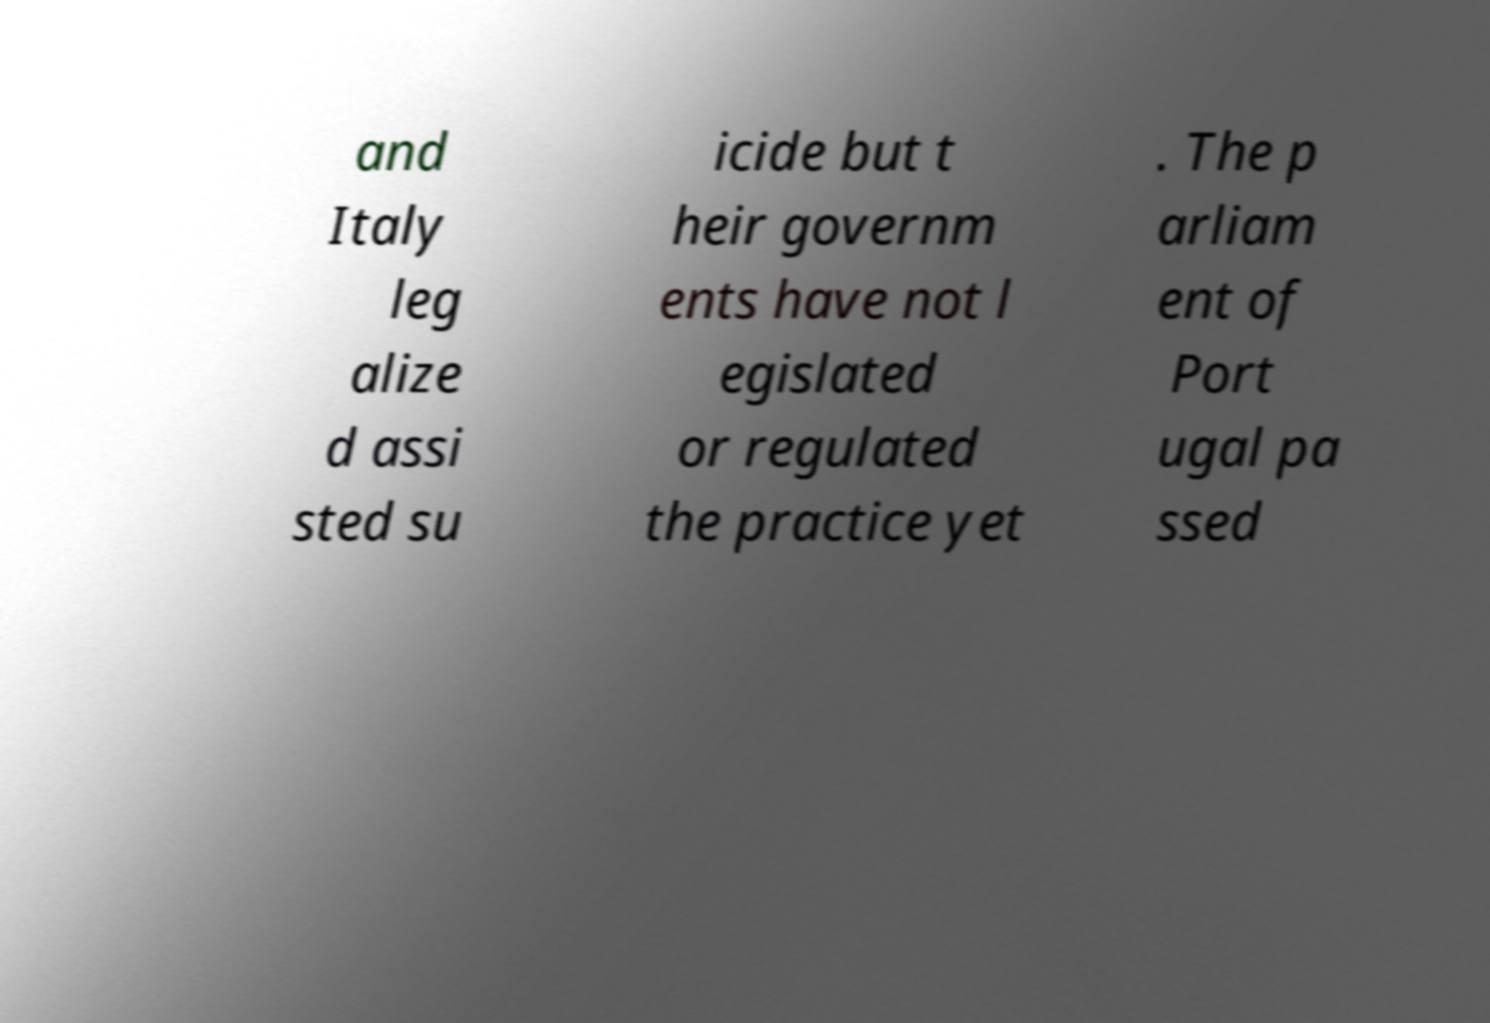Could you extract and type out the text from this image? and Italy leg alize d assi sted su icide but t heir governm ents have not l egislated or regulated the practice yet . The p arliam ent of Port ugal pa ssed 